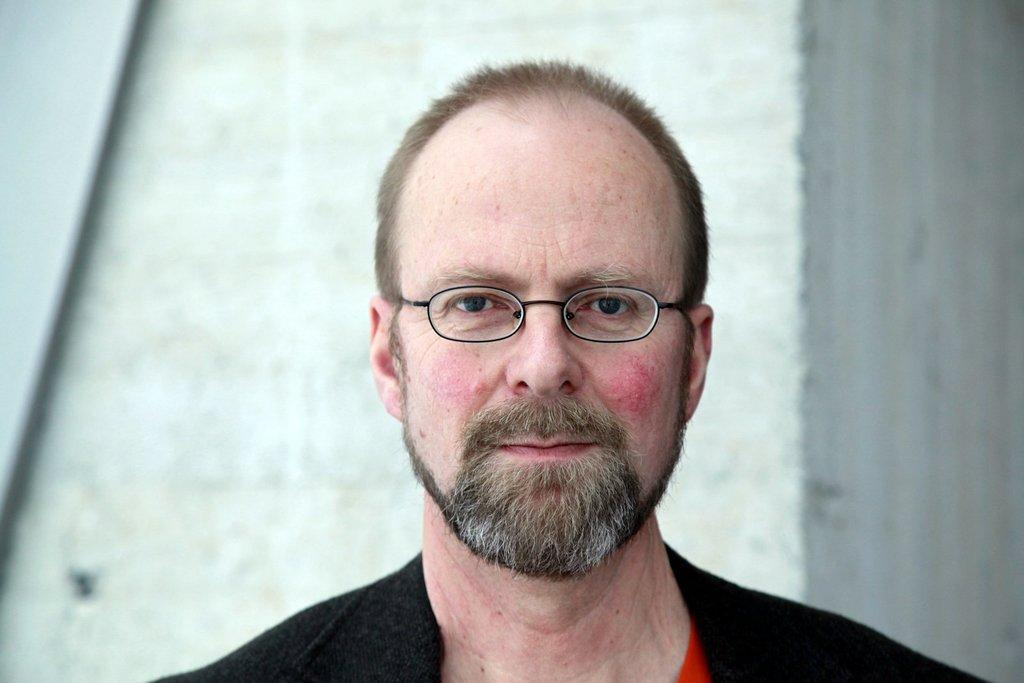What is present in the image? There is a man in the image. Can you describe the man's clothing? The man is wearing black clothes. Does the man have any accessories in the image? Yes, the man is wearing glasses. What is the color of the wall in the image? There is a white color wall in the image. What type of sound does the engine make in the image? There is no engine present in the image, so it is not possible to determine the sound it might make. 